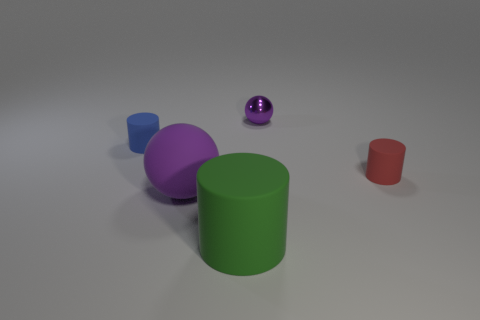Subtract all big green cylinders. How many cylinders are left? 2 Add 4 small yellow objects. How many objects exist? 9 Subtract all red cylinders. How many cylinders are left? 2 Subtract all cylinders. How many objects are left? 2 Subtract 0 cyan balls. How many objects are left? 5 Subtract 2 cylinders. How many cylinders are left? 1 Subtract all blue balls. Subtract all brown cubes. How many balls are left? 2 Subtract all large brown cylinders. Subtract all tiny red matte objects. How many objects are left? 4 Add 1 blue rubber cylinders. How many blue rubber cylinders are left? 2 Add 1 small gray cylinders. How many small gray cylinders exist? 1 